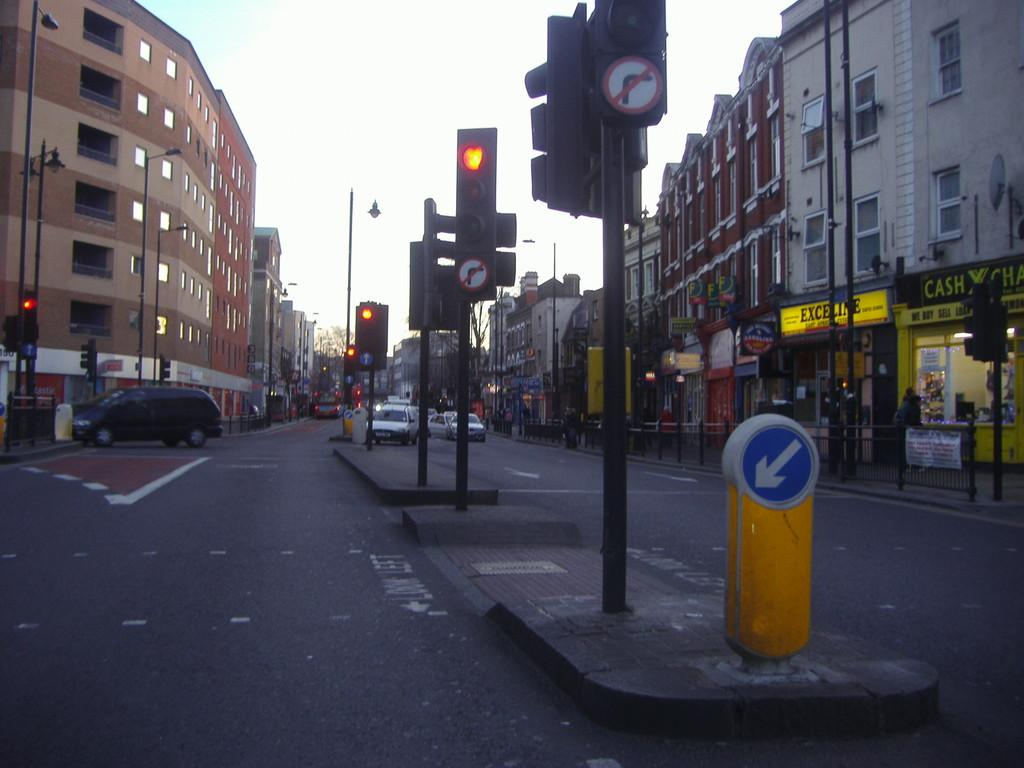<image>
Provide a brief description of the given image. A cluster of traffic signals in a city intersection by a building that says Cash. 